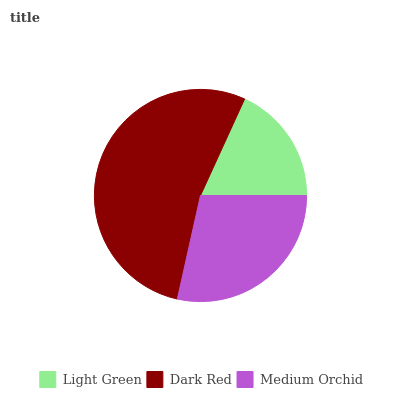Is Light Green the minimum?
Answer yes or no. Yes. Is Dark Red the maximum?
Answer yes or no. Yes. Is Medium Orchid the minimum?
Answer yes or no. No. Is Medium Orchid the maximum?
Answer yes or no. No. Is Dark Red greater than Medium Orchid?
Answer yes or no. Yes. Is Medium Orchid less than Dark Red?
Answer yes or no. Yes. Is Medium Orchid greater than Dark Red?
Answer yes or no. No. Is Dark Red less than Medium Orchid?
Answer yes or no. No. Is Medium Orchid the high median?
Answer yes or no. Yes. Is Medium Orchid the low median?
Answer yes or no. Yes. Is Light Green the high median?
Answer yes or no. No. Is Light Green the low median?
Answer yes or no. No. 